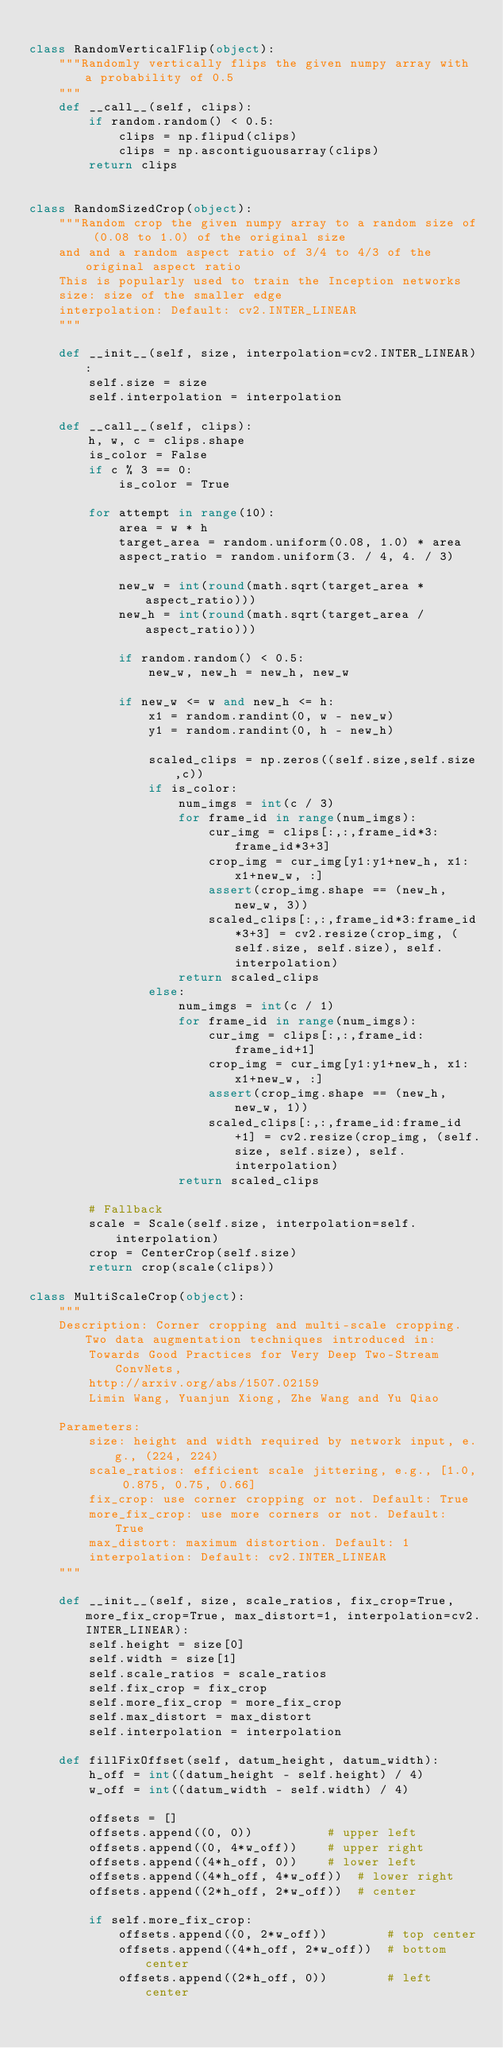Convert code to text. <code><loc_0><loc_0><loc_500><loc_500><_Python_>
class RandomVerticalFlip(object):
    """Randomly vertically flips the given numpy array with a probability of 0.5
    """
    def __call__(self, clips):
        if random.random() < 0.5:
            clips = np.flipud(clips)
            clips = np.ascontiguousarray(clips)
        return clips


class RandomSizedCrop(object):
    """Random crop the given numpy array to a random size of (0.08 to 1.0) of the original size
    and and a random aspect ratio of 3/4 to 4/3 of the original aspect ratio
    This is popularly used to train the Inception networks
    size: size of the smaller edge
    interpolation: Default: cv2.INTER_LINEAR
    """

    def __init__(self, size, interpolation=cv2.INTER_LINEAR):
        self.size = size
        self.interpolation = interpolation

    def __call__(self, clips):
        h, w, c = clips.shape
        is_color = False
        if c % 3 == 0:
            is_color = True

        for attempt in range(10):
            area = w * h
            target_area = random.uniform(0.08, 1.0) * area
            aspect_ratio = random.uniform(3. / 4, 4. / 3)

            new_w = int(round(math.sqrt(target_area * aspect_ratio)))
            new_h = int(round(math.sqrt(target_area / aspect_ratio)))

            if random.random() < 0.5:
                new_w, new_h = new_h, new_w

            if new_w <= w and new_h <= h:
                x1 = random.randint(0, w - new_w)
                y1 = random.randint(0, h - new_h)

                scaled_clips = np.zeros((self.size,self.size,c))
                if is_color:
                    num_imgs = int(c / 3)
                    for frame_id in range(num_imgs):
                        cur_img = clips[:,:,frame_id*3:frame_id*3+3]
                        crop_img = cur_img[y1:y1+new_h, x1:x1+new_w, :]
                        assert(crop_img.shape == (new_h, new_w, 3))
                        scaled_clips[:,:,frame_id*3:frame_id*3+3] = cv2.resize(crop_img, (self.size, self.size), self.interpolation)
                    return scaled_clips
                else:
                    num_imgs = int(c / 1)
                    for frame_id in range(num_imgs):
                        cur_img = clips[:,:,frame_id:frame_id+1]
                        crop_img = cur_img[y1:y1+new_h, x1:x1+new_w, :]
                        assert(crop_img.shape == (new_h, new_w, 1))
                        scaled_clips[:,:,frame_id:frame_id+1] = cv2.resize(crop_img, (self.size, self.size), self.interpolation)
                    return scaled_clips

        # Fallback
        scale = Scale(self.size, interpolation=self.interpolation)
        crop = CenterCrop(self.size)
        return crop(scale(clips))

class MultiScaleCrop(object):
    """
    Description: Corner cropping and multi-scale cropping. Two data augmentation techniques introduced in:
        Towards Good Practices for Very Deep Two-Stream ConvNets,
        http://arxiv.org/abs/1507.02159
        Limin Wang, Yuanjun Xiong, Zhe Wang and Yu Qiao

    Parameters:
        size: height and width required by network input, e.g., (224, 224)
        scale_ratios: efficient scale jittering, e.g., [1.0, 0.875, 0.75, 0.66]
        fix_crop: use corner cropping or not. Default: True
        more_fix_crop: use more corners or not. Default: True
        max_distort: maximum distortion. Default: 1
        interpolation: Default: cv2.INTER_LINEAR
    """

    def __init__(self, size, scale_ratios, fix_crop=True, more_fix_crop=True, max_distort=1, interpolation=cv2.INTER_LINEAR):
        self.height = size[0]
        self.width = size[1]
        self.scale_ratios = scale_ratios
        self.fix_crop = fix_crop
        self.more_fix_crop = more_fix_crop
        self.max_distort = max_distort
        self.interpolation = interpolation

    def fillFixOffset(self, datum_height, datum_width):
        h_off = int((datum_height - self.height) / 4)
        w_off = int((datum_width - self.width) / 4)

        offsets = []
        offsets.append((0, 0))          # upper left
        offsets.append((0, 4*w_off))    # upper right
        offsets.append((4*h_off, 0))    # lower left
        offsets.append((4*h_off, 4*w_off))  # lower right
        offsets.append((2*h_off, 2*w_off))  # center

        if self.more_fix_crop:
            offsets.append((0, 2*w_off))        # top center
            offsets.append((4*h_off, 2*w_off))  # bottom center
            offsets.append((2*h_off, 0))        # left center</code> 